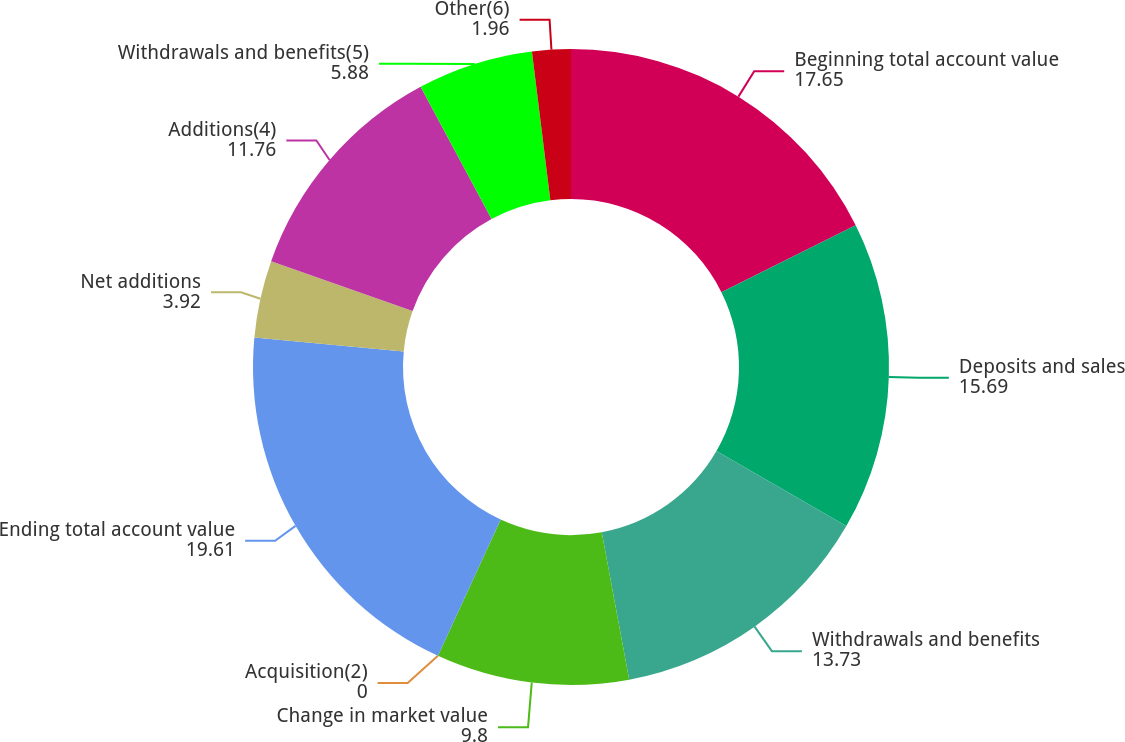<chart> <loc_0><loc_0><loc_500><loc_500><pie_chart><fcel>Beginning total account value<fcel>Deposits and sales<fcel>Withdrawals and benefits<fcel>Change in market value<fcel>Acquisition(2)<fcel>Ending total account value<fcel>Net additions<fcel>Additions(4)<fcel>Withdrawals and benefits(5)<fcel>Other(6)<nl><fcel>17.65%<fcel>15.69%<fcel>13.73%<fcel>9.8%<fcel>0.0%<fcel>19.61%<fcel>3.92%<fcel>11.76%<fcel>5.88%<fcel>1.96%<nl></chart> 